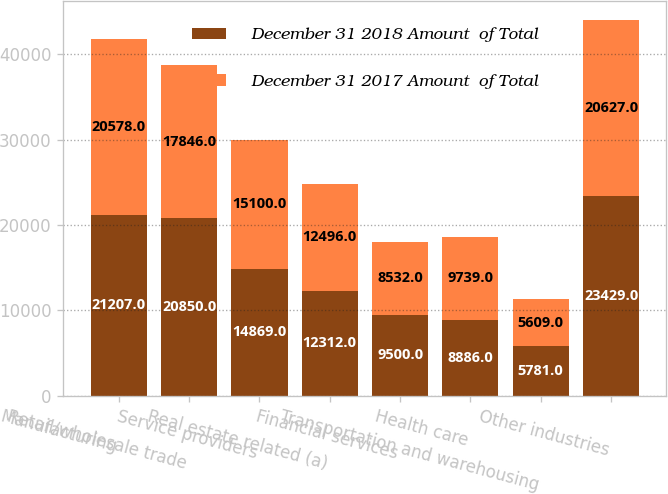<chart> <loc_0><loc_0><loc_500><loc_500><stacked_bar_chart><ecel><fcel>Manufacturing<fcel>Retail/wholesale trade<fcel>Service providers<fcel>Real estate related (a)<fcel>Financial services<fcel>Health care<fcel>Transportation and warehousing<fcel>Other industries<nl><fcel>December 31 2018 Amount  of Total<fcel>21207<fcel>20850<fcel>14869<fcel>12312<fcel>9500<fcel>8886<fcel>5781<fcel>23429<nl><fcel>December 31 2017 Amount  of Total<fcel>20578<fcel>17846<fcel>15100<fcel>12496<fcel>8532<fcel>9739<fcel>5609<fcel>20627<nl></chart> 